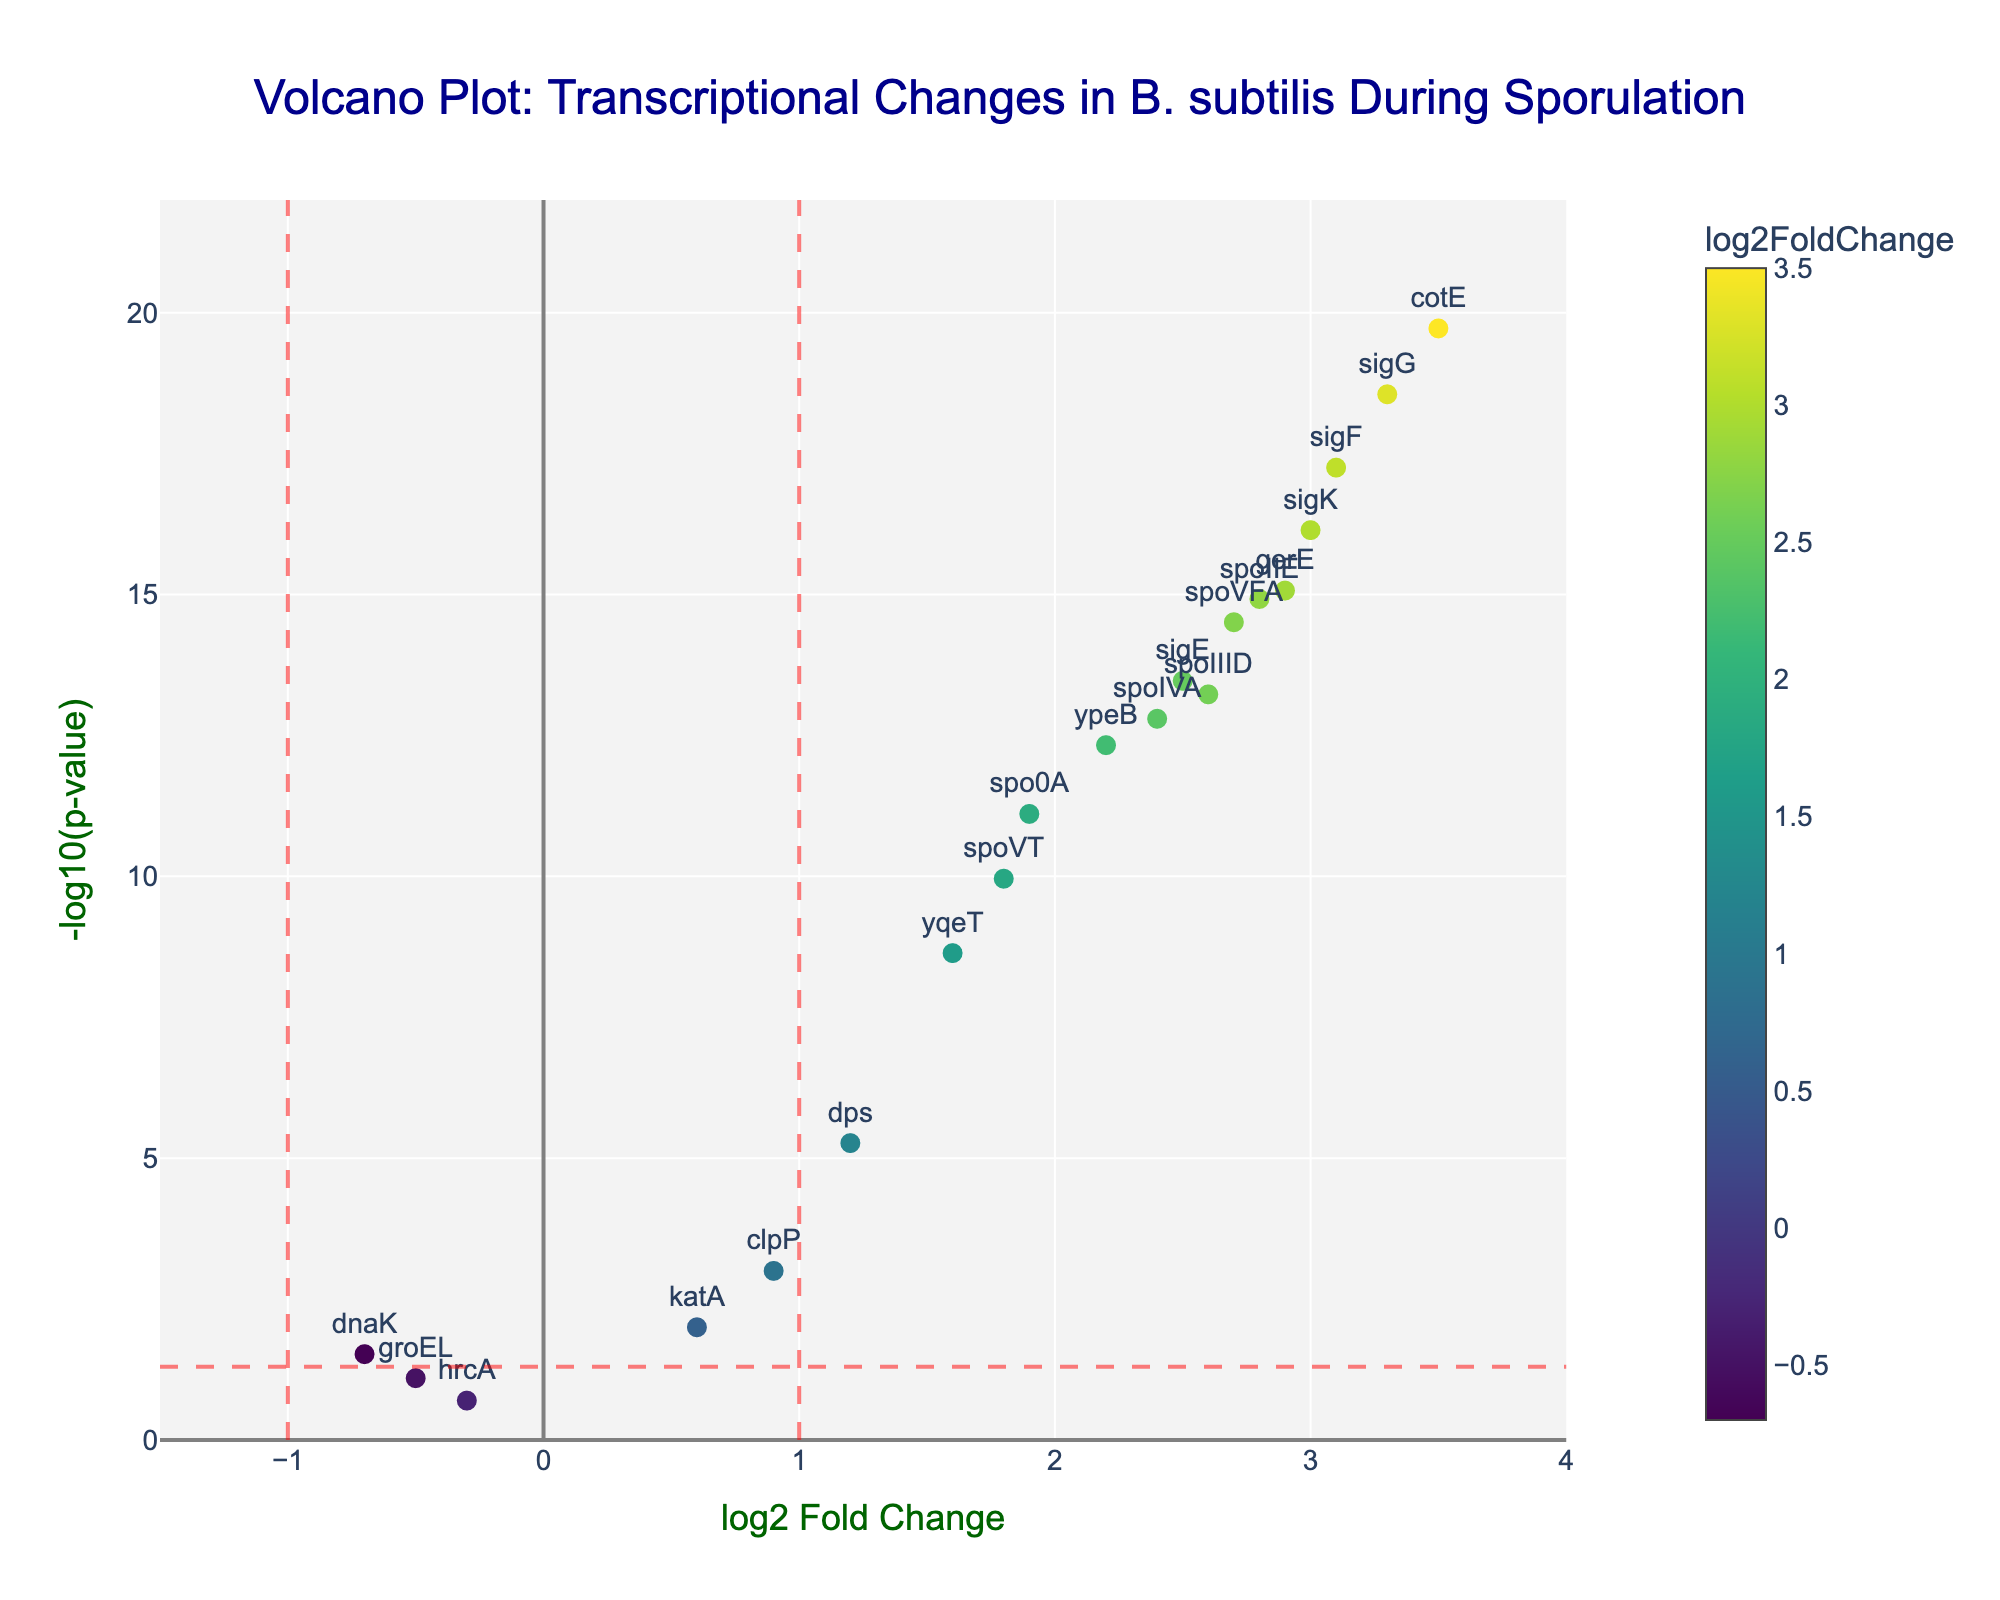What is the title of the figure? The title is located at the top center of the figure. It reads: "Volcano Plot: Transcriptional Changes in B. subtilis During Sporulation".
Answer: Volcano Plot: Transcriptional Changes in B. subtilis During Sporulation How many genes have a log2FoldChange greater than 2? By looking at the x-axis, focus on genes to the right of the x=2 line. The genes in this region are spoIIE, sigF, sigE, ypeB, cotE, gerE, sigG, and sigK, totaling 8 genes.
Answer: 8 genes Which gene has the highest -log10(p-value)? By examining the y-axis, the highest point corresponds to the gene "cotE" with the highest -log10(p-value).
Answer: cotE What is the log2FoldChange of the gene with the lowest p-value? The gene with the lowest p-value is cotE, as indicated by its highest -log10(p-value) on the y-axis. The log2FoldChange of cotE is 3.5.
Answer: 3.5 How many genes have a p-value lower than 0.05? The horizontal red line indicates p-value = 0.05 or -log10(p-value) of around 1.3. Counting the points above this line gives 17 genes.
Answer: 17 genes Which gene has the smallest positive log2FoldChange? By examining the points with positive log2FoldChange values, the smallest positive log2FoldChange value is 0.6, corresponding to the gene katA.
Answer: katA Which genes have both a log2FoldChange greater than 1 and a -log10(p-value) greater than 10? Looking to the right of x = 1 and above y = 10, the only gene that satisfies both conditions is sigF.
Answer: sigF How many stress-related genes (dnaK, groEL, clpP, hrcA, dps, katA) are significantly regulated (p-value < 0.05)? Marking the stress-related genes and checking their p-values, we find dnaK, clpP, dps, and katA have p-values below 0.05. That sums up to 4 stress-related genes.
Answer: 4 genes Which genes have a log2FoldChange between 1 and 2 and also a -log10(p-value) greater than 5? Focusing on the region with 1 < log2FoldChange < 2 and -log10(p-value) > 5, the genes yqeT, spoVT, and dps meet these criteria.
Answer: yqeT, spoVT, dps What is the median log2FoldChange of all the genes? Sorting the log2FoldChange values: -0.7, -0.5, -0.3, 0.6, 0.9, 1.2, 1.6, 1.8, 1.9, 2.2, 2.4, 2.5, 2.6, 2.7, 2.8, 2.9, 3.0, 3.1, 3.3, 3.5. With 20 values, the median (average of the 10th and 11th values) is (2.2 + 2.4)/2 = 2.3.
Answer: 2.3 